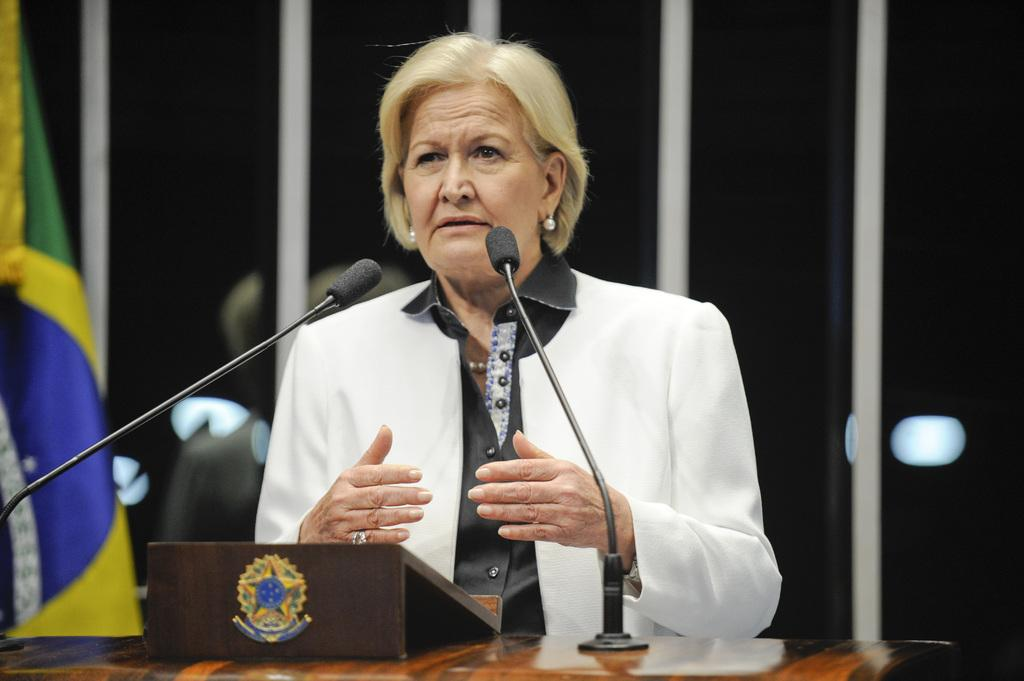Who is the main subject in the image? There is a woman in the image. What is the woman doing in the image? The woman is speaking. What objects are in front of the woman? There are two microphones in front of the woman. What can be seen in the background of the image on the left side? There is a flag in the background of the image on the left side. How much salt is desired by the woman in the image? There is no mention of salt or desire in the image, so it cannot be determined from the image. 